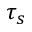Convert formula to latex. <formula><loc_0><loc_0><loc_500><loc_500>\tau _ { s }</formula> 